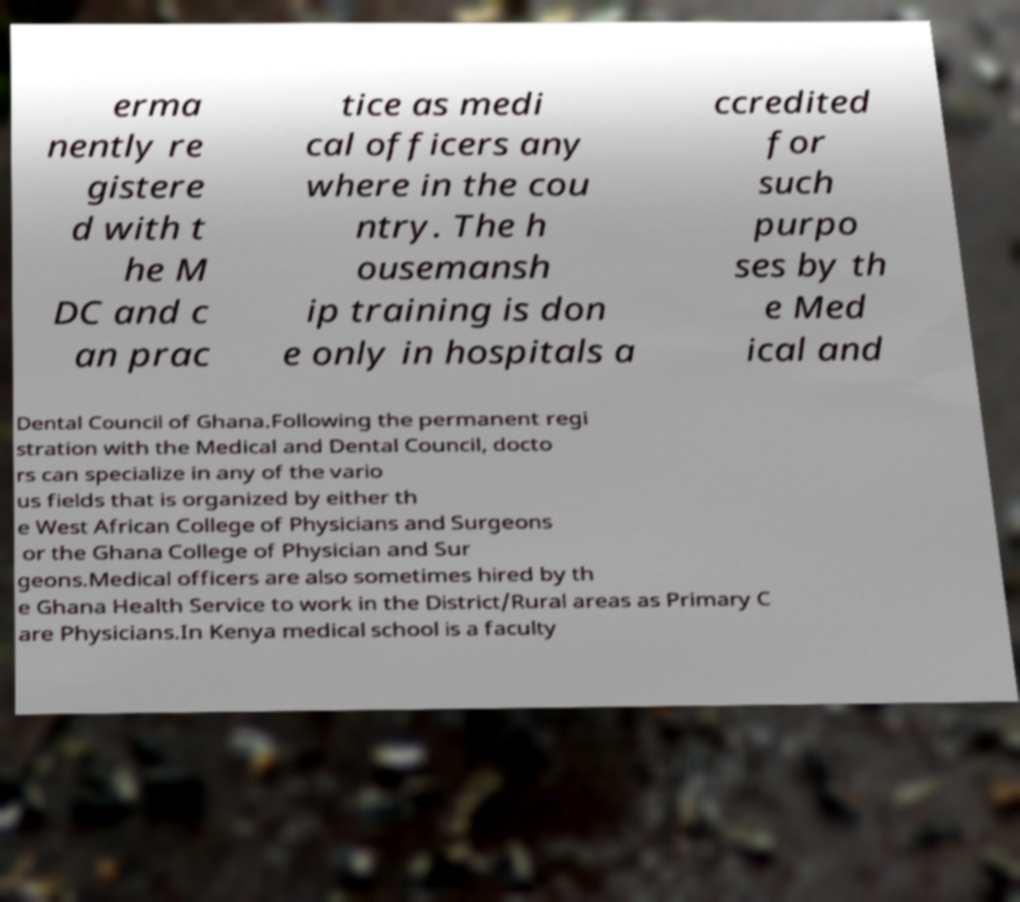Please identify and transcribe the text found in this image. erma nently re gistere d with t he M DC and c an prac tice as medi cal officers any where in the cou ntry. The h ousemansh ip training is don e only in hospitals a ccredited for such purpo ses by th e Med ical and Dental Council of Ghana.Following the permanent regi stration with the Medical and Dental Council, docto rs can specialize in any of the vario us fields that is organized by either th e West African College of Physicians and Surgeons or the Ghana College of Physician and Sur geons.Medical officers are also sometimes hired by th e Ghana Health Service to work in the District/Rural areas as Primary C are Physicians.In Kenya medical school is a faculty 